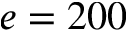<formula> <loc_0><loc_0><loc_500><loc_500>e = 2 0 0</formula> 